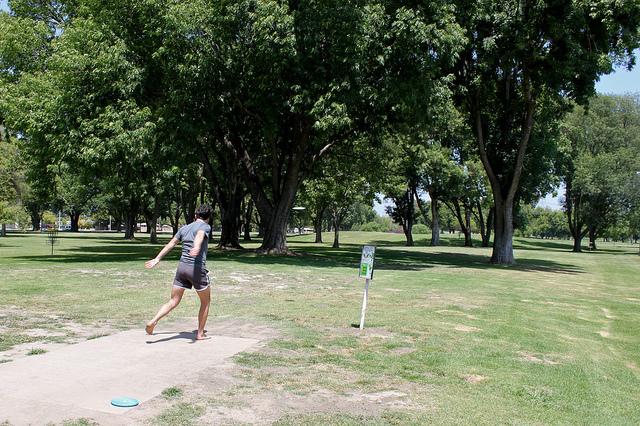What does this park offer for frisbee players?
Keep it brief. Frisbee golf. Is this at a beach?
Give a very brief answer. No. What is the child running on top of?
Concise answer only. Dirt. Are there just a couple trees?
Quick response, please. No. 